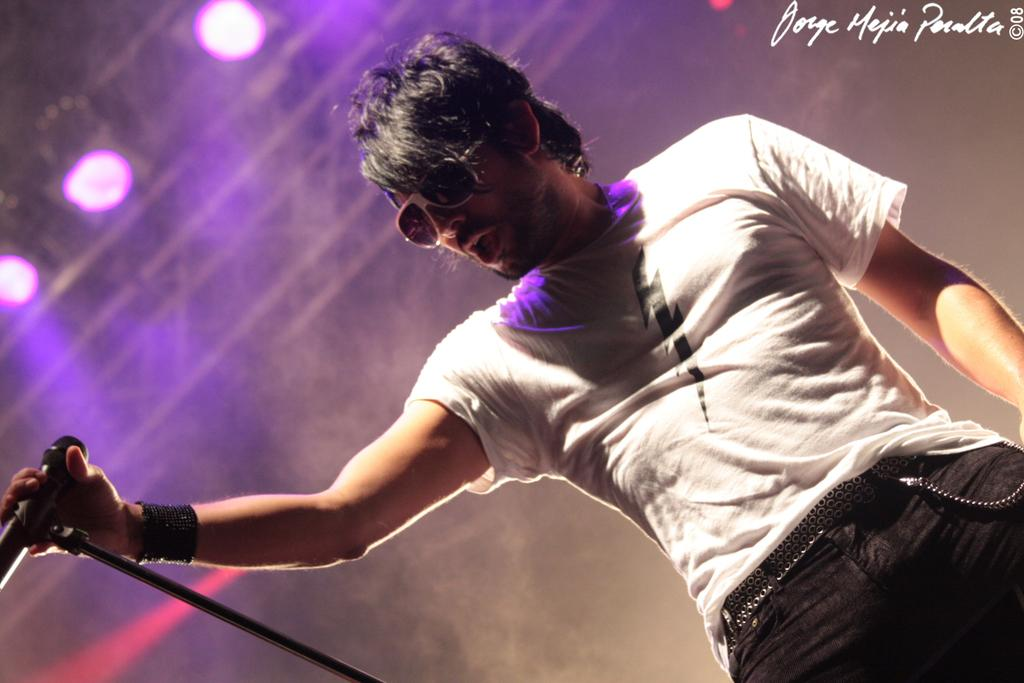What is the main subject of the image? There is a person in the image. What is the person wearing? The person is wearing a white t-shirt. What is the person doing in the image? The person is standing and singing. What object is the person holding? The person is holding a microphone. What can be seen at the top of the image? There are lights visible at the top of the image. What is present in the top right corner of the image? There is text in the top right corner of the image. What direction is the person writing in the image? There is no writing present in the image, so it is not possible to determine the direction in which the person might be writing. 